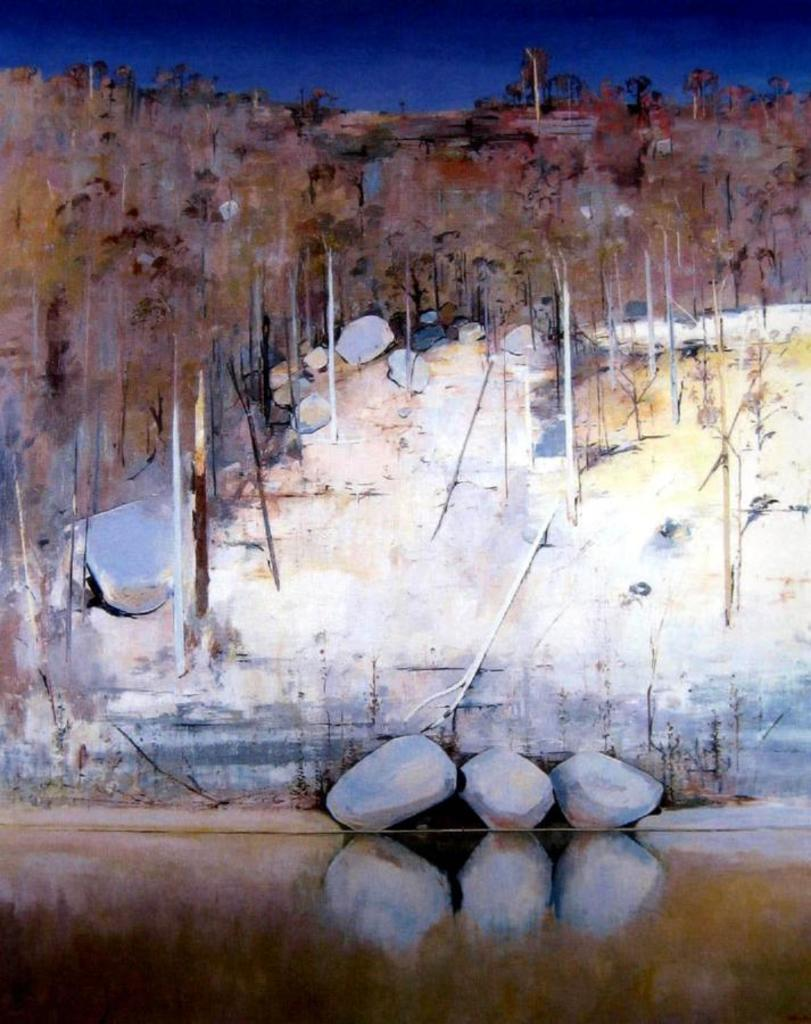What can be seen in the sky in the image? The sky is visible in the image. What type of vegetation is present in the image? There are trees in the image. What other natural elements can be seen in the image? There are rocks and grass in the image. How is the grass depicted in the image? The grass is truncated towards the bottom of the image. Can you hear the people laughing in the image? There are no people or sounds present in the image, so it is not possible to hear any laughter. 